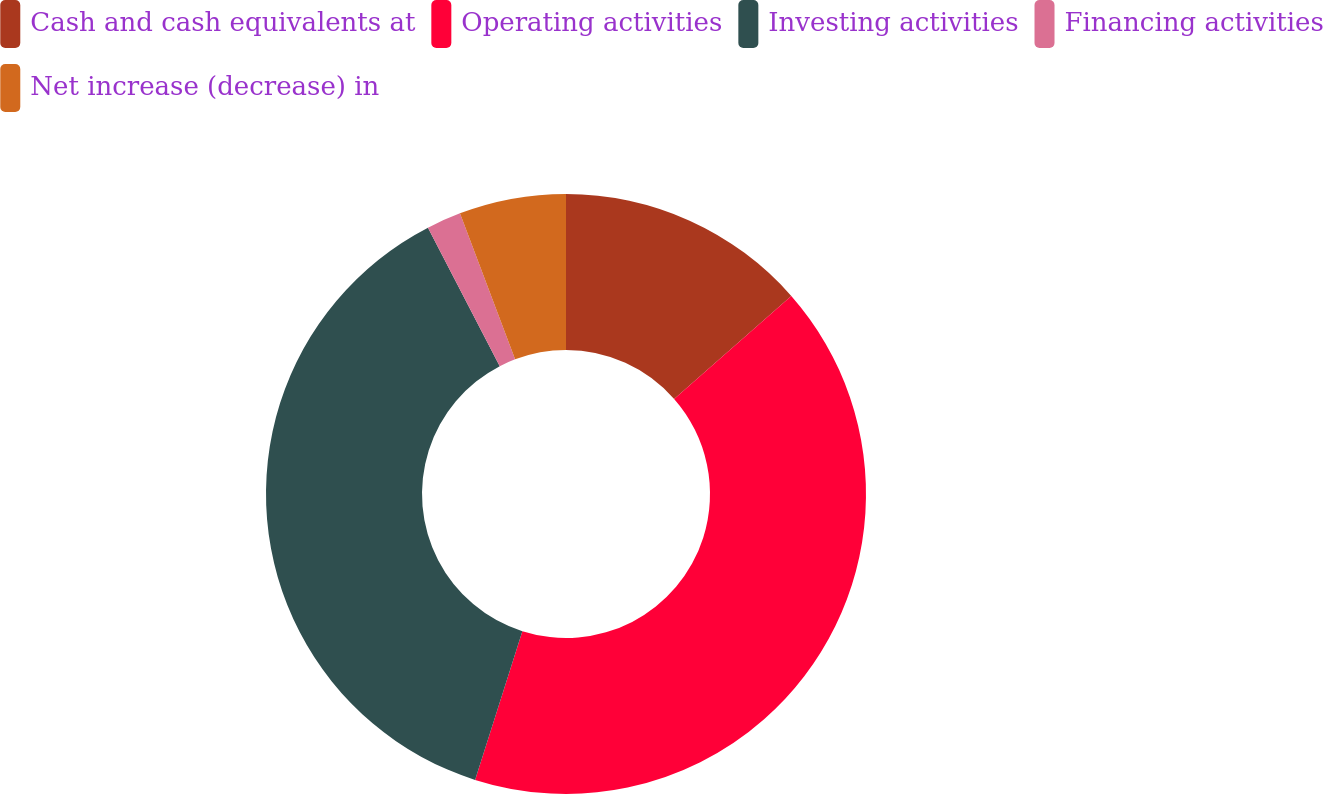<chart> <loc_0><loc_0><loc_500><loc_500><pie_chart><fcel>Cash and cash equivalents at<fcel>Operating activities<fcel>Investing activities<fcel>Financing activities<fcel>Net increase (decrease) in<nl><fcel>13.52%<fcel>41.38%<fcel>37.49%<fcel>1.86%<fcel>5.75%<nl></chart> 